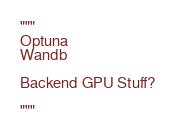Convert code to text. <code><loc_0><loc_0><loc_500><loc_500><_Python_>"""
Optuna
Wandb

Backend GPU Stuff?

"""
</code> 